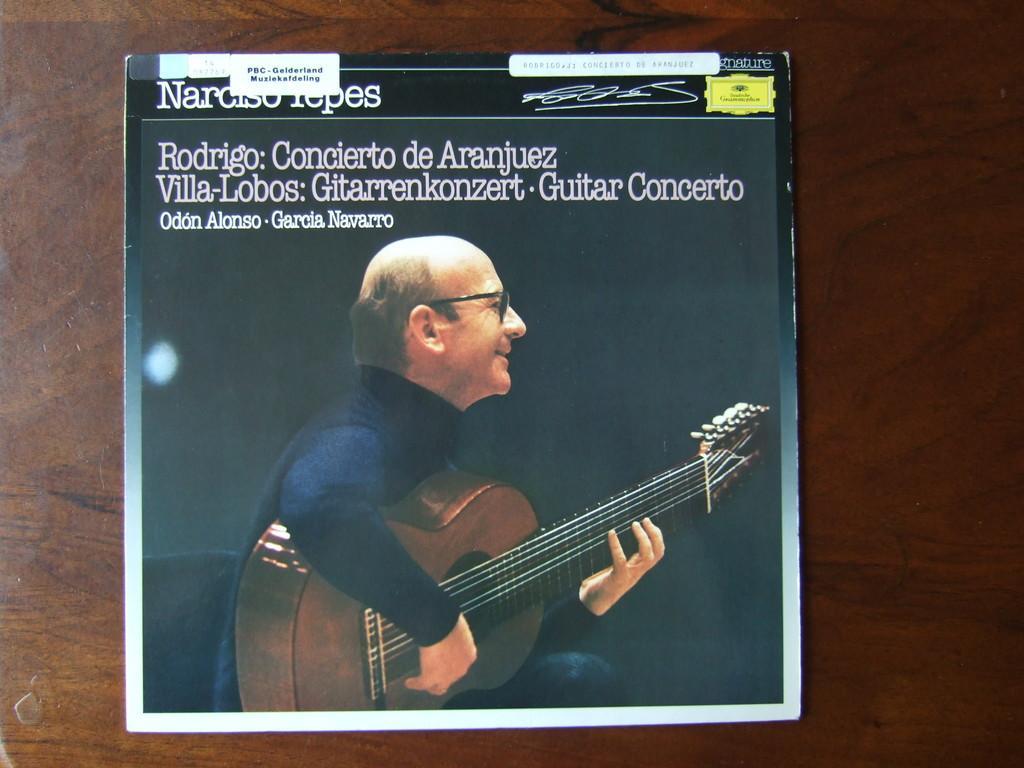Describe this image in one or two sentences. In this image, we can see a poster on the surface. We can see some image and text on the poster. 